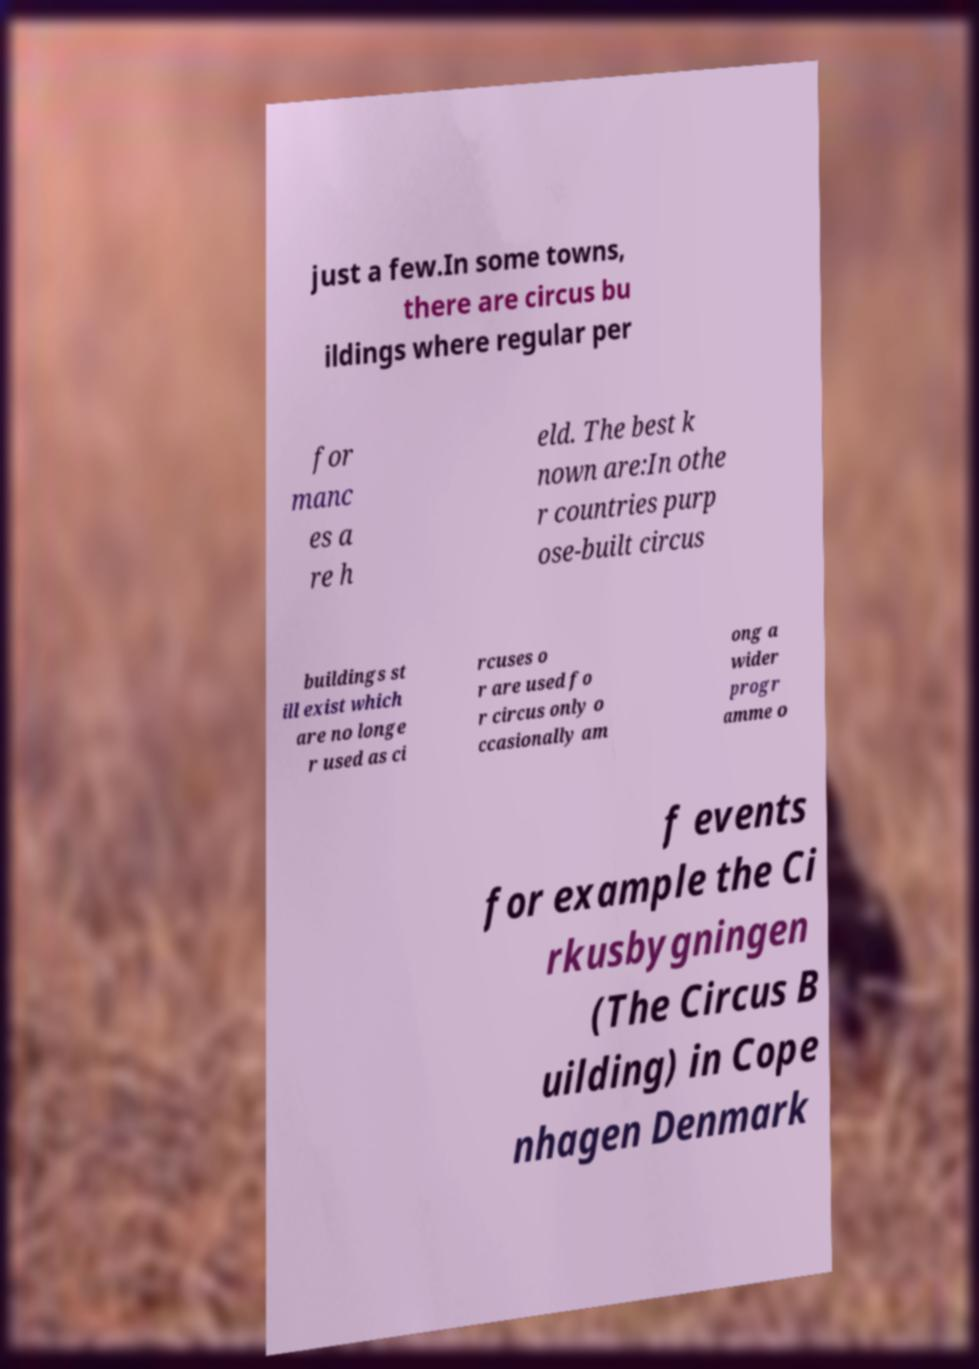Could you extract and type out the text from this image? just a few.In some towns, there are circus bu ildings where regular per for manc es a re h eld. The best k nown are:In othe r countries purp ose-built circus buildings st ill exist which are no longe r used as ci rcuses o r are used fo r circus only o ccasionally am ong a wider progr amme o f events for example the Ci rkusbygningen (The Circus B uilding) in Cope nhagen Denmark 